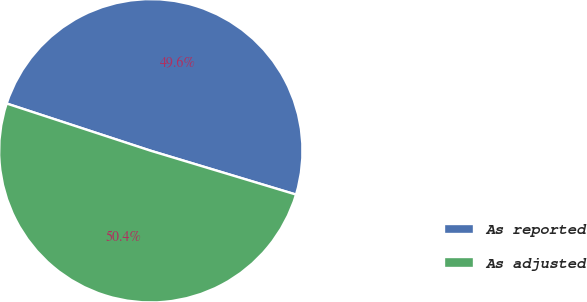Convert chart to OTSL. <chart><loc_0><loc_0><loc_500><loc_500><pie_chart><fcel>As reported<fcel>As adjusted<nl><fcel>49.62%<fcel>50.38%<nl></chart> 